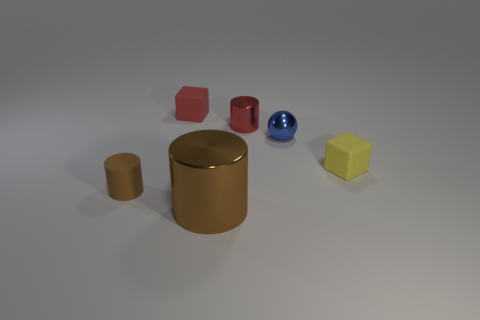Can we guess the material of the objects shown? The objects in the image have a matte and smooth surface, suggesting they could be made of plastic or a similar material, although without additional context it's difficult to determine the exact materials. Are the objects solid or hollow? The image doesn't provide enough information to ascertain whether the objects are solid or hollow, as both types can have a similar appearance. 